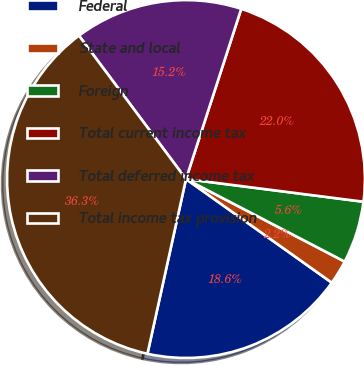Convert chart. <chart><loc_0><loc_0><loc_500><loc_500><pie_chart><fcel>Federal<fcel>State and local<fcel>Foreign<fcel>Total current income tax<fcel>Total deferred income tax<fcel>Total income tax provision<nl><fcel>18.62%<fcel>2.2%<fcel>5.61%<fcel>22.03%<fcel>15.2%<fcel>36.34%<nl></chart> 